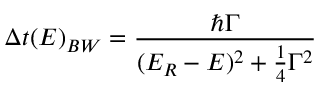Convert formula to latex. <formula><loc_0><loc_0><loc_500><loc_500>\Delta t ( E ) _ { B W } = { \frac { \hbar { \Gamma } } { ( E _ { R } - E ) ^ { 2 } + { \frac { 1 } { 4 } } \Gamma ^ { 2 } } }</formula> 